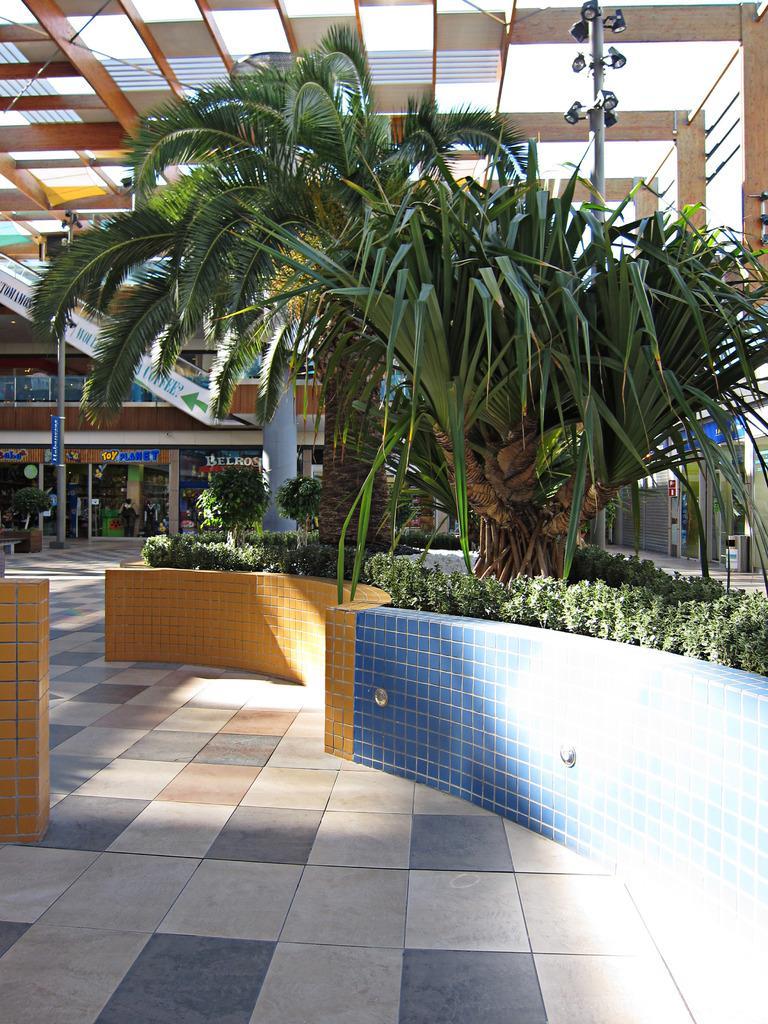In one or two sentences, can you explain what this image depicts? In this image we can see few stores. There are two trees and many plants in the image. There is a dustbin, a pole and fewer lamps connected to it. 